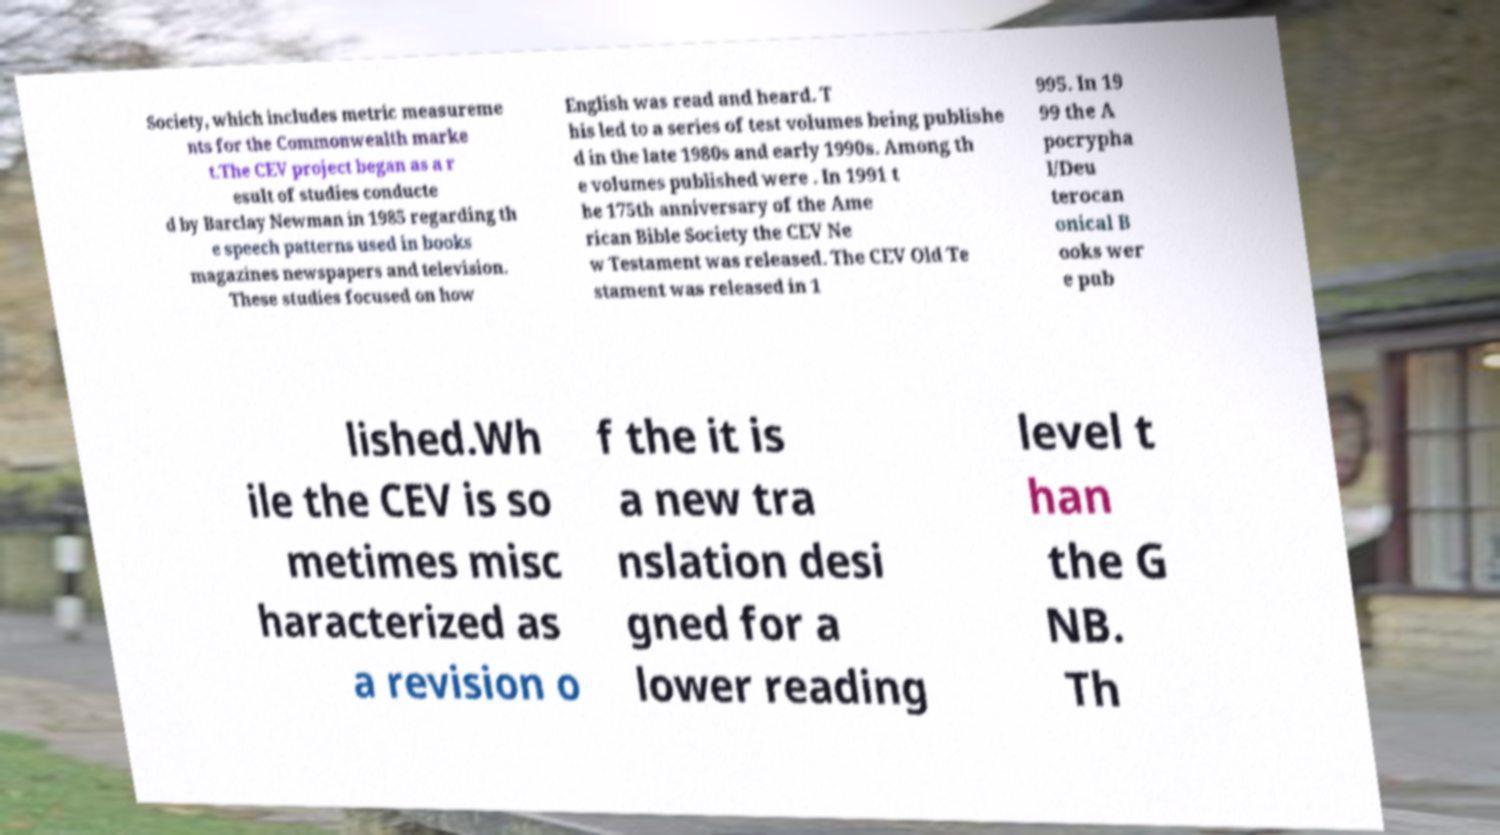Can you read and provide the text displayed in the image?This photo seems to have some interesting text. Can you extract and type it out for me? Society, which includes metric measureme nts for the Commonwealth marke t.The CEV project began as a r esult of studies conducte d by Barclay Newman in 1985 regarding th e speech patterns used in books magazines newspapers and television. These studies focused on how English was read and heard. T his led to a series of test volumes being publishe d in the late 1980s and early 1990s. Among th e volumes published were . In 1991 t he 175th anniversary of the Ame rican Bible Society the CEV Ne w Testament was released. The CEV Old Te stament was released in 1 995. In 19 99 the A pocrypha l/Deu terocan onical B ooks wer e pub lished.Wh ile the CEV is so metimes misc haracterized as a revision o f the it is a new tra nslation desi gned for a lower reading level t han the G NB. Th 